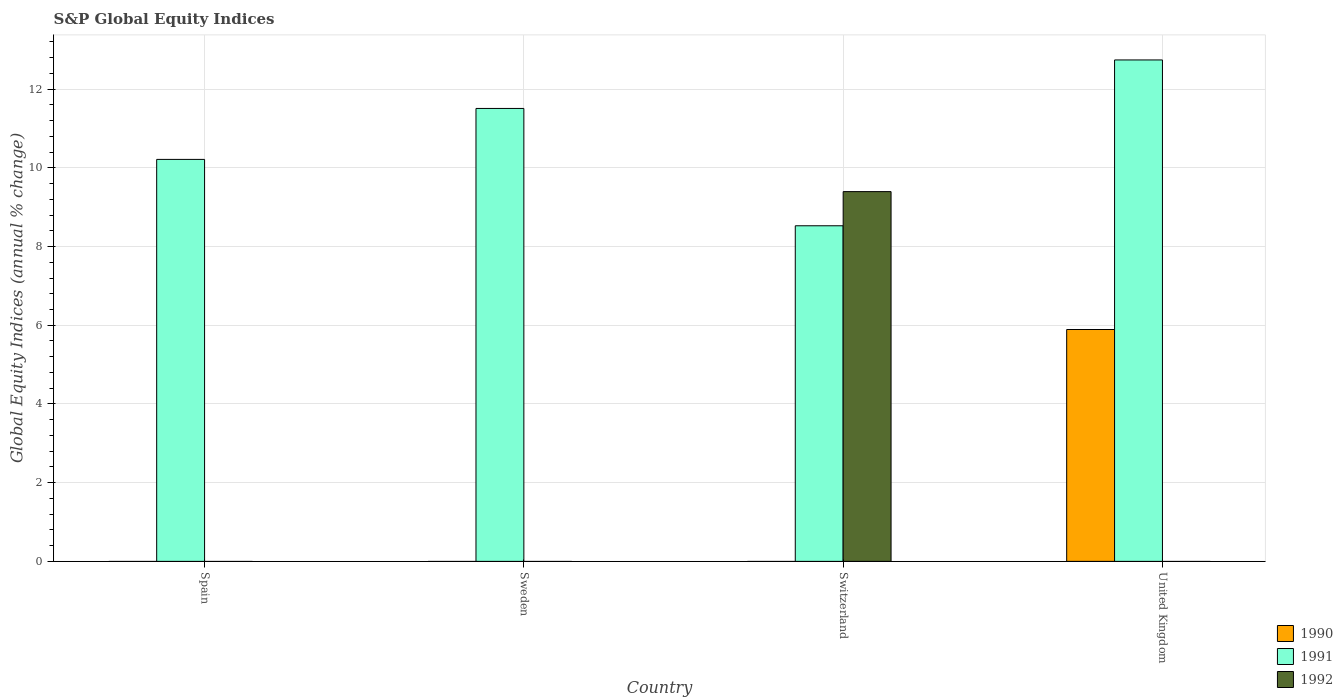How many different coloured bars are there?
Your answer should be very brief. 3. Are the number of bars per tick equal to the number of legend labels?
Your answer should be compact. No. In how many cases, is the number of bars for a given country not equal to the number of legend labels?
Offer a terse response. 4. Across all countries, what is the maximum global equity indices in 1992?
Provide a succinct answer. 9.4. Across all countries, what is the minimum global equity indices in 1991?
Provide a succinct answer. 8.53. In which country was the global equity indices in 1992 maximum?
Offer a terse response. Switzerland. What is the total global equity indices in 1991 in the graph?
Offer a very short reply. 42.99. What is the difference between the global equity indices in 1991 in Sweden and that in United Kingdom?
Make the answer very short. -1.23. What is the difference between the global equity indices in 1991 in Switzerland and the global equity indices in 1992 in Sweden?
Give a very brief answer. 8.53. What is the average global equity indices in 1992 per country?
Your answer should be very brief. 2.35. What is the difference between the global equity indices of/in 1992 and global equity indices of/in 1991 in Switzerland?
Offer a terse response. 0.87. What is the ratio of the global equity indices in 1991 in Spain to that in United Kingdom?
Give a very brief answer. 0.8. Is the global equity indices in 1991 in Switzerland less than that in United Kingdom?
Ensure brevity in your answer.  Yes. What is the difference between the highest and the second highest global equity indices in 1991?
Give a very brief answer. -1.29. What is the difference between the highest and the lowest global equity indices in 1991?
Ensure brevity in your answer.  4.21. Is it the case that in every country, the sum of the global equity indices in 1992 and global equity indices in 1990 is greater than the global equity indices in 1991?
Provide a succinct answer. No. How many bars are there?
Keep it short and to the point. 6. Are all the bars in the graph horizontal?
Give a very brief answer. No. Does the graph contain any zero values?
Offer a terse response. Yes. Does the graph contain grids?
Provide a short and direct response. Yes. Where does the legend appear in the graph?
Your answer should be compact. Bottom right. How are the legend labels stacked?
Offer a very short reply. Vertical. What is the title of the graph?
Give a very brief answer. S&P Global Equity Indices. What is the label or title of the Y-axis?
Provide a succinct answer. Global Equity Indices (annual % change). What is the Global Equity Indices (annual % change) of 1991 in Spain?
Offer a very short reply. 10.21. What is the Global Equity Indices (annual % change) of 1991 in Sweden?
Your answer should be very brief. 11.51. What is the Global Equity Indices (annual % change) in 1992 in Sweden?
Your answer should be very brief. 0. What is the Global Equity Indices (annual % change) of 1990 in Switzerland?
Your response must be concise. 0. What is the Global Equity Indices (annual % change) of 1991 in Switzerland?
Your answer should be very brief. 8.53. What is the Global Equity Indices (annual % change) of 1992 in Switzerland?
Provide a succinct answer. 9.4. What is the Global Equity Indices (annual % change) in 1990 in United Kingdom?
Ensure brevity in your answer.  5.89. What is the Global Equity Indices (annual % change) of 1991 in United Kingdom?
Your response must be concise. 12.74. What is the Global Equity Indices (annual % change) of 1992 in United Kingdom?
Keep it short and to the point. 0. Across all countries, what is the maximum Global Equity Indices (annual % change) of 1990?
Offer a very short reply. 5.89. Across all countries, what is the maximum Global Equity Indices (annual % change) in 1991?
Offer a very short reply. 12.74. Across all countries, what is the maximum Global Equity Indices (annual % change) in 1992?
Give a very brief answer. 9.4. Across all countries, what is the minimum Global Equity Indices (annual % change) of 1990?
Your answer should be very brief. 0. Across all countries, what is the minimum Global Equity Indices (annual % change) in 1991?
Give a very brief answer. 8.53. What is the total Global Equity Indices (annual % change) of 1990 in the graph?
Your answer should be compact. 5.89. What is the total Global Equity Indices (annual % change) in 1991 in the graph?
Ensure brevity in your answer.  42.99. What is the total Global Equity Indices (annual % change) in 1992 in the graph?
Your response must be concise. 9.4. What is the difference between the Global Equity Indices (annual % change) in 1991 in Spain and that in Sweden?
Your answer should be very brief. -1.29. What is the difference between the Global Equity Indices (annual % change) in 1991 in Spain and that in Switzerland?
Keep it short and to the point. 1.69. What is the difference between the Global Equity Indices (annual % change) in 1991 in Spain and that in United Kingdom?
Your response must be concise. -2.53. What is the difference between the Global Equity Indices (annual % change) of 1991 in Sweden and that in Switzerland?
Make the answer very short. 2.98. What is the difference between the Global Equity Indices (annual % change) in 1991 in Sweden and that in United Kingdom?
Make the answer very short. -1.23. What is the difference between the Global Equity Indices (annual % change) of 1991 in Switzerland and that in United Kingdom?
Your answer should be compact. -4.21. What is the difference between the Global Equity Indices (annual % change) in 1991 in Spain and the Global Equity Indices (annual % change) in 1992 in Switzerland?
Provide a succinct answer. 0.82. What is the difference between the Global Equity Indices (annual % change) in 1991 in Sweden and the Global Equity Indices (annual % change) in 1992 in Switzerland?
Make the answer very short. 2.11. What is the average Global Equity Indices (annual % change) of 1990 per country?
Your response must be concise. 1.47. What is the average Global Equity Indices (annual % change) in 1991 per country?
Provide a succinct answer. 10.75. What is the average Global Equity Indices (annual % change) of 1992 per country?
Provide a short and direct response. 2.35. What is the difference between the Global Equity Indices (annual % change) in 1991 and Global Equity Indices (annual % change) in 1992 in Switzerland?
Give a very brief answer. -0.87. What is the difference between the Global Equity Indices (annual % change) of 1990 and Global Equity Indices (annual % change) of 1991 in United Kingdom?
Offer a terse response. -6.85. What is the ratio of the Global Equity Indices (annual % change) of 1991 in Spain to that in Sweden?
Your answer should be compact. 0.89. What is the ratio of the Global Equity Indices (annual % change) in 1991 in Spain to that in Switzerland?
Ensure brevity in your answer.  1.2. What is the ratio of the Global Equity Indices (annual % change) in 1991 in Spain to that in United Kingdom?
Ensure brevity in your answer.  0.8. What is the ratio of the Global Equity Indices (annual % change) in 1991 in Sweden to that in Switzerland?
Make the answer very short. 1.35. What is the ratio of the Global Equity Indices (annual % change) in 1991 in Sweden to that in United Kingdom?
Offer a very short reply. 0.9. What is the ratio of the Global Equity Indices (annual % change) in 1991 in Switzerland to that in United Kingdom?
Give a very brief answer. 0.67. What is the difference between the highest and the second highest Global Equity Indices (annual % change) of 1991?
Your response must be concise. 1.23. What is the difference between the highest and the lowest Global Equity Indices (annual % change) in 1990?
Keep it short and to the point. 5.89. What is the difference between the highest and the lowest Global Equity Indices (annual % change) in 1991?
Your answer should be compact. 4.21. What is the difference between the highest and the lowest Global Equity Indices (annual % change) of 1992?
Make the answer very short. 9.4. 